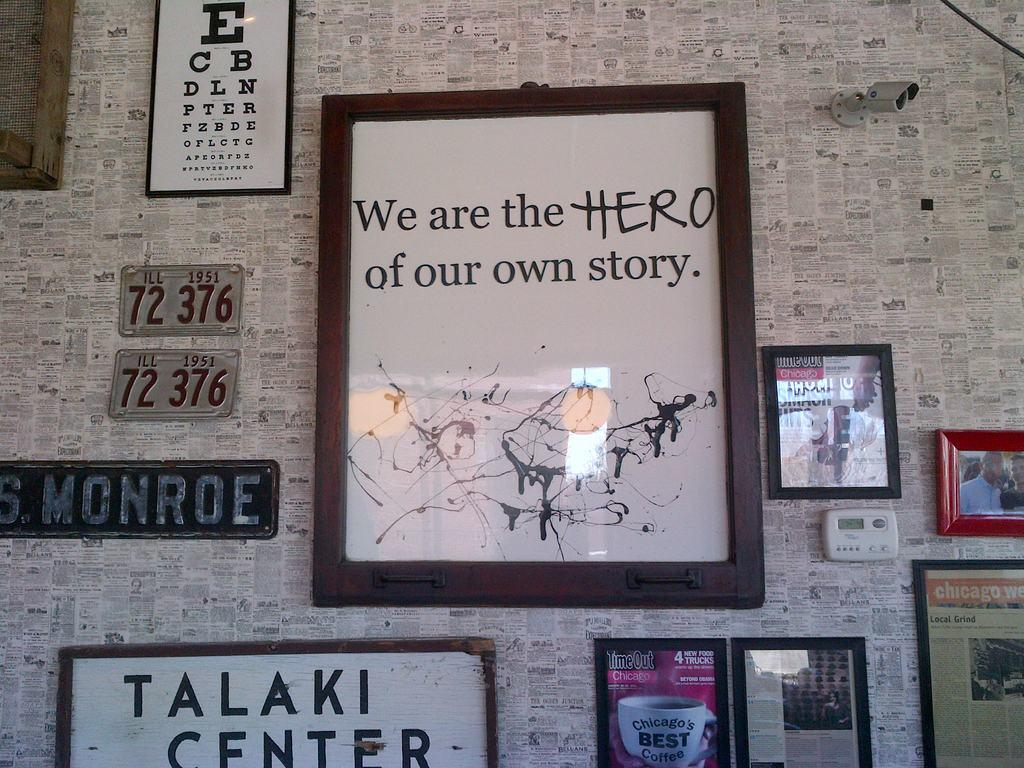<image>
Present a compact description of the photo's key features. lots pictures hung on the wall one says we are the hero 